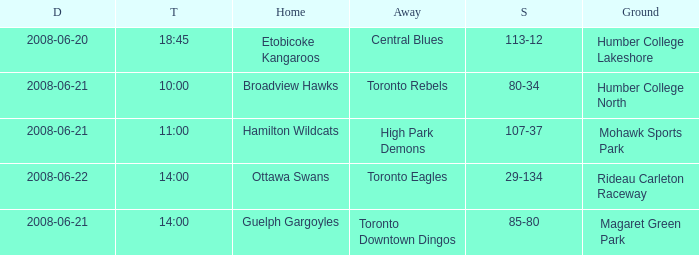What is the Time with a Ground that is humber college north? 10:00. 